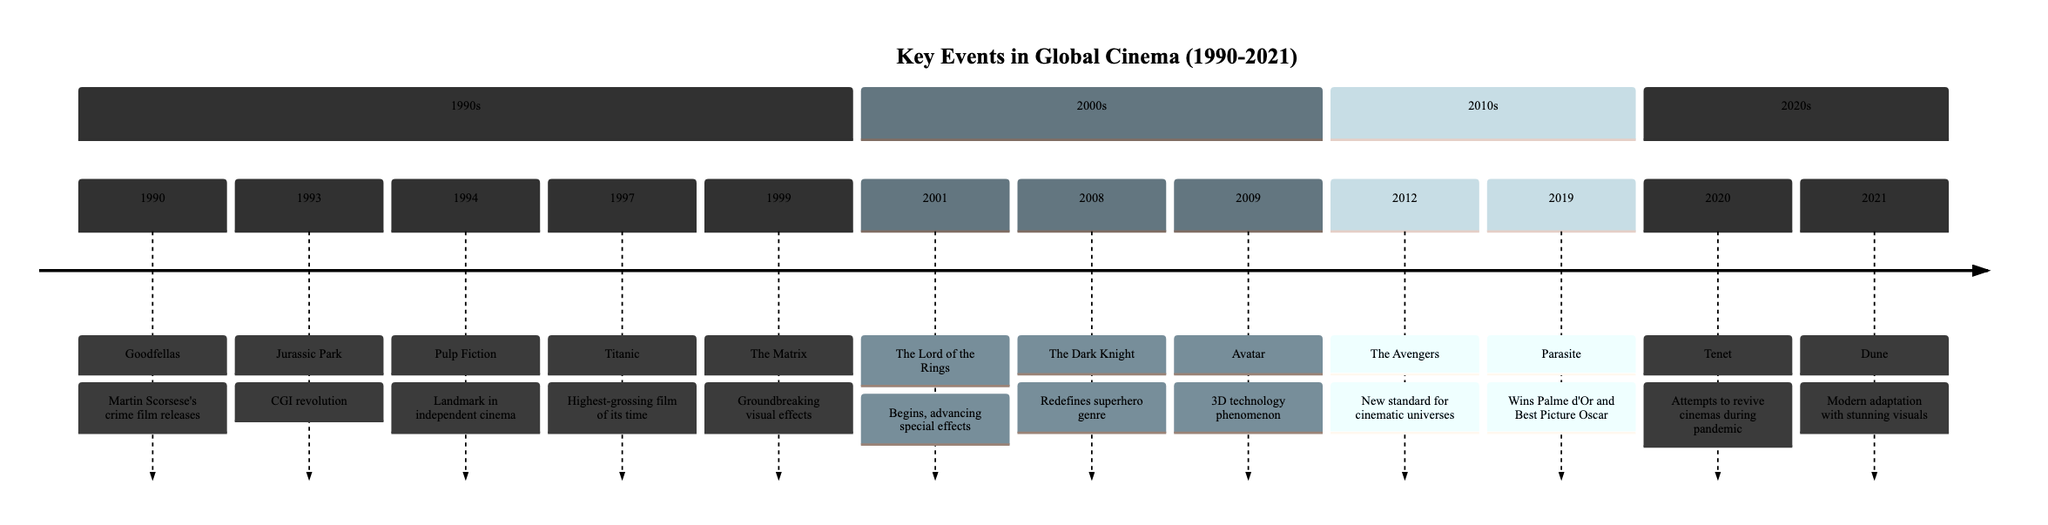What film released in 1994 became a landmark in independent cinema? The diagram indicates that Quentin Tarantino's 'Pulp Fiction' was released in 1994 and is recognized as a landmark in independent cinema.
Answer: Pulp Fiction How many key events are noted in the 1990s section? By counting the events listed in the 1990s section of the diagram, we see there are five noted key events: Goodfellas, Jurassic Park, Pulp Fiction, Titanic, and The Matrix.
Answer: 5 Which film is associated with the year 2008 and redefined the superhero genre? The timeline specifies that 'The Dark Knight', directed by Christopher Nolan, is associated with the year 2008 and is noted for redefining the superhero genre.
Answer: The Dark Knight What technological innovation is highlighted with the release of 'Avatar' in 2009? The diagram indicates that James Cameron’s 'Avatar' in 2009 utilized 3D technology and became a global phenomenon, marking a significant technological innovation for cinema.
Answer: 3D technology Which director’s work won the Palme d’Or and later the Academy Award for Best Picture in 2019? According to the timeline, Bong Joon-ho directed 'Parasite', which won the Palme d’Or and the Academy Award for Best Picture in 2019.
Answer: Bong Joon-ho What genre did 'The Matrix' significantly impact upon its release? The event description associated with 'The Matrix' states that it introduced groundbreaking visual effects and philosophical themes, indicating its influential impact on science fiction.
Answer: Science fiction Which film, released in 2012, set a new standard for interconnected cinematic universes? The timeline specifies that 'The Avengers', released in 2012, is credited with setting a new standard for interconnected cinematic universes.
Answer: The Avengers How many sections are present in the timeline and what is the last section called? The timeline contains four sections, and the last section covering events is labeled as the '2020s'. There are events listed for each decade from the 1990s to the 2020s.
Answer: 2020s 